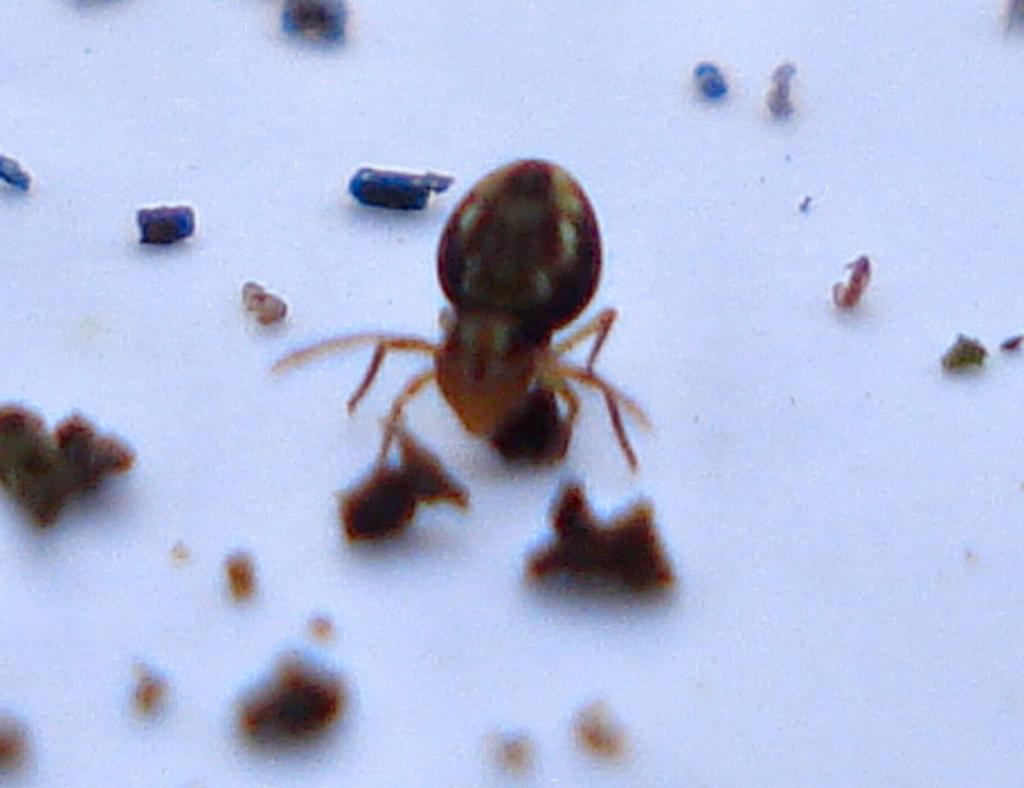What color is the floor in the image? The floor in the image is white. What type of creature can be seen in the image? There is an ant in the image. What else is present in the image besides the ant? There are food particles in the image. How many degrees does the bridge have in the image? There is no bridge present in the image. What is the condition of the knee of the person in the image? There is no person present in the image, only an ant and food particles. 